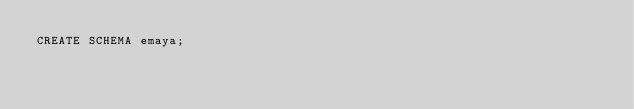<code> <loc_0><loc_0><loc_500><loc_500><_SQL_>CREATE SCHEMA emaya;</code> 